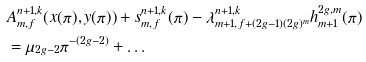<formula> <loc_0><loc_0><loc_500><loc_500>& A ^ { n + 1 , k } _ { m , f } ( x ( \pi ) , y ( \pi ) ) + s ^ { n + 1 , k } _ { m , f } ( \pi ) - \lambda ^ { n + 1 , k } _ { m + 1 , f + ( 2 g - 1 ) ( 2 g ) ^ { m } } h ^ { 2 g , m } _ { m + 1 } ( \pi ) \\ & = \mu _ { 2 g - 2 } \pi ^ { - ( 2 g - 2 ) } + \dots</formula> 